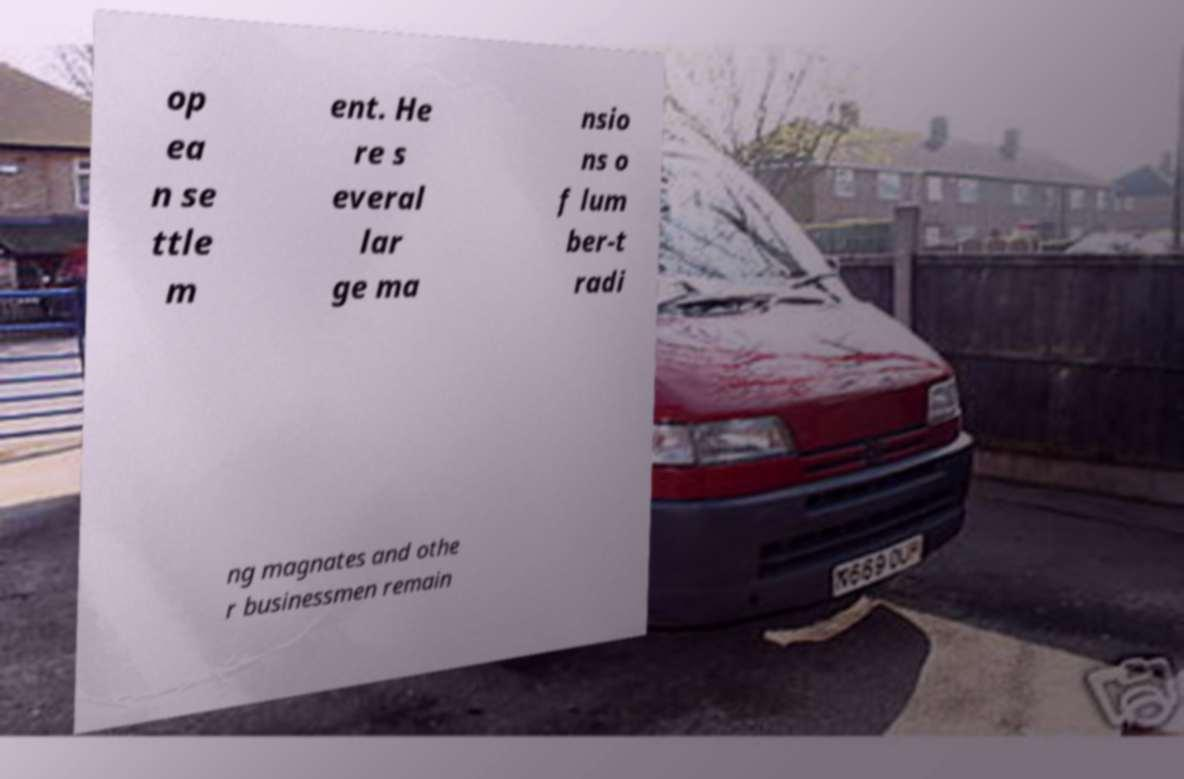Can you accurately transcribe the text from the provided image for me? op ea n se ttle m ent. He re s everal lar ge ma nsio ns o f lum ber-t radi ng magnates and othe r businessmen remain 